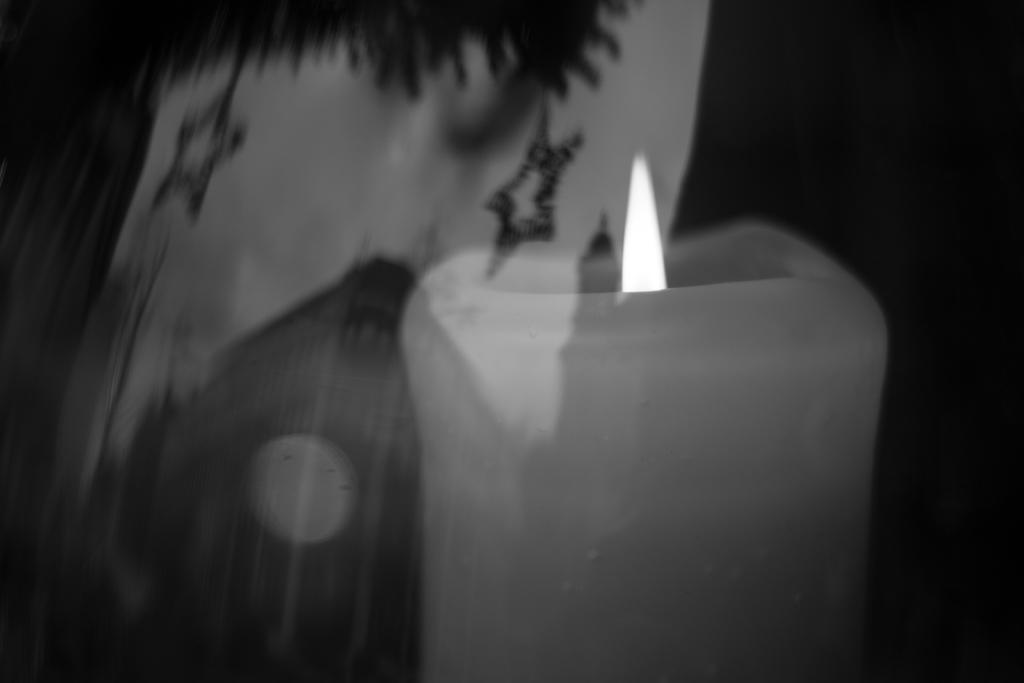Can you describe this image briefly? In this picture we can see a candle and an object and in the background we can see it is dark. 